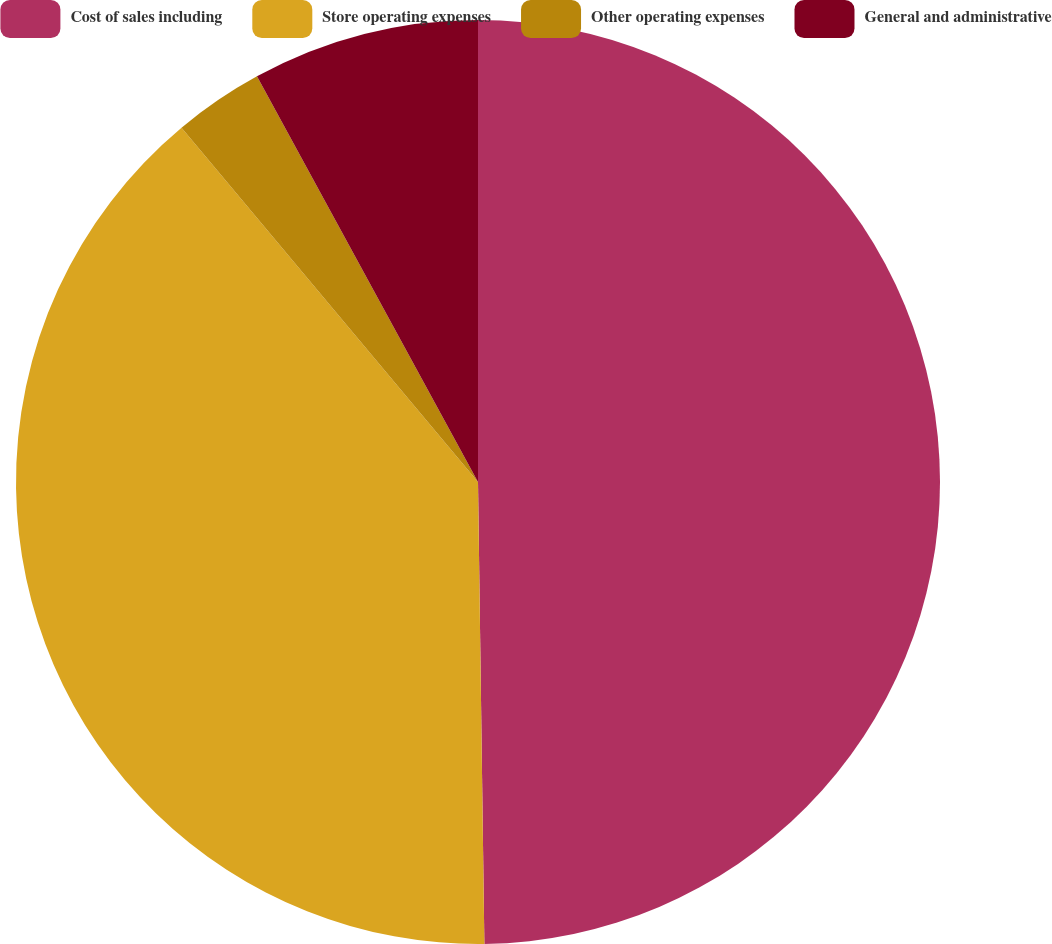Convert chart to OTSL. <chart><loc_0><loc_0><loc_500><loc_500><pie_chart><fcel>Cost of sales including<fcel>Store operating expenses<fcel>Other operating expenses<fcel>General and administrative<nl><fcel>49.78%<fcel>39.13%<fcel>3.15%<fcel>7.94%<nl></chart> 